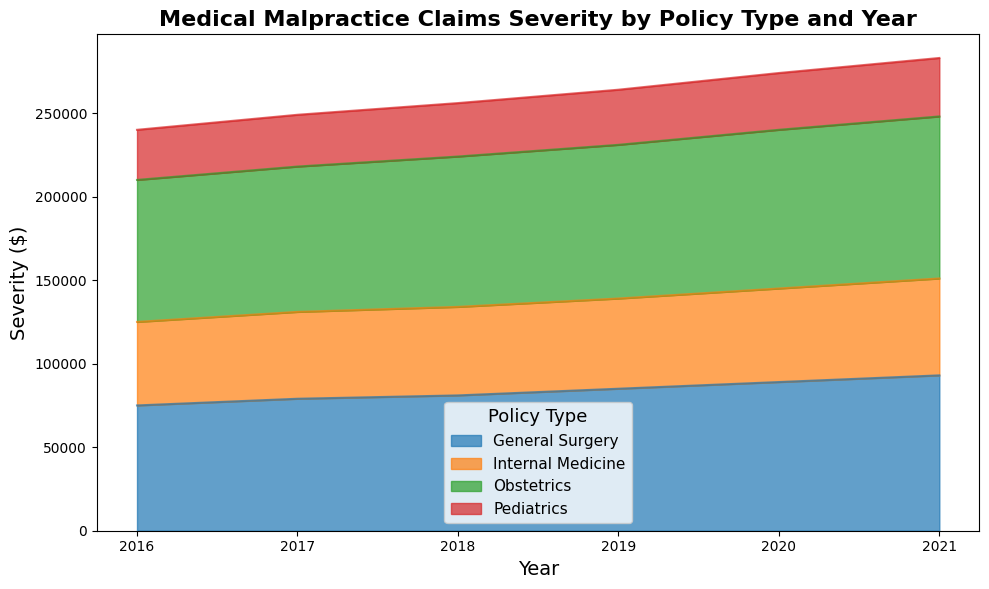What is the trend in the severity of medical malpractice claims for General Surgery from 2016 to 2021? Observing the area covering General Surgery from 2016 to 2021, we see a consistent upward trend. The height of the area increases each year, indicating a rise in the severity of claims over time.
Answer: Increasing Which policy type had the highest severity in 2020? Looking at the height of areas in 2020, the Obstetrics policy type has the highest peak, indicating the highest severity in 2020.
Answer: Obstetrics Compare the severity of medical malpractice claims for Pediatrics between 2017 and 2021. Is there an increase or decrease, and by how much? In 2017, the severity for Pediatrics is 31,000. In 2021, it is 35,000. The difference between 2021 and 2017 is 35,000 - 31,000 = 4,000. This indicates an increase of 4,000 over this period.
Answer: Increase by 4,000 Between General Surgery and Internal Medicine, which policy type shows a higher rate of increase in claim severity from 2016 to 2021? General Surgery's severity rises from 75,000 in 2016 to 93,000 in 2021, an increase of 18,000. Internal Medicine's severity increases from 50,000 in 2016 to 58,000 in 2021, an increase of 8,000. The increase for General Surgery (18,000) is higher compared to Internal Medicine (8,000).
Answer: General Surgery In what year did Obstetrics see the largest year-over-year increase in claim severity? Comparing subsequent years: 
2016 to 2017: 87,000 - 85,000 = 2,000
2017 to 2018: 90,000 - 87,000 = 3,000
2018 to 2019: 92,000 - 90,000 = 2,000
2019 to 2020: 95,000 - 92,000 = 3,000
2020 to 2021: 97,000 - 95,000 = 2,000
The largest increase of 3,000 occurred between 2017 to 2018 and 2019 to 2020.
Answer: 2018 or 2020 What is the average severity of claims for Internal Medicine over the entire period? The severities are: 2016: 50,000, 2017: 52,000, 2018: 53,000, 2019: 54,000, 2020: 56,000, 2021: 58,000. Summing these: 50,000 + 52,000 + 53,000 + 54,000 + 56,000 + 58,000 = 323,000. Dividing by the number of years (6): 323,000 / 6 = 53,833.33.
Answer: 53,833.33 How does the severity of Obstetrics claims in 2021 compare to the severity of Pediatrics claims in 2016? The severity for Obstetrics in 2021 is 97,000. The severity for Pediatrics in 2016 is 30,000. Comparing both, Obstetrics in 2021 is much higher by 97,000 - 30,000 = 67,000.
Answer: 67,000 higher What is the total severity in 2018 for all policy types combined? The severities for 2018 are: General Surgery: 81,000, Internal Medicine: 53,000, Obstetrics: 90,000, Pediatrics: 32,000. Summing these: 81,000 + 53,000 + 90,000 + 32,000 = 256,000.
Answer: 256,000 